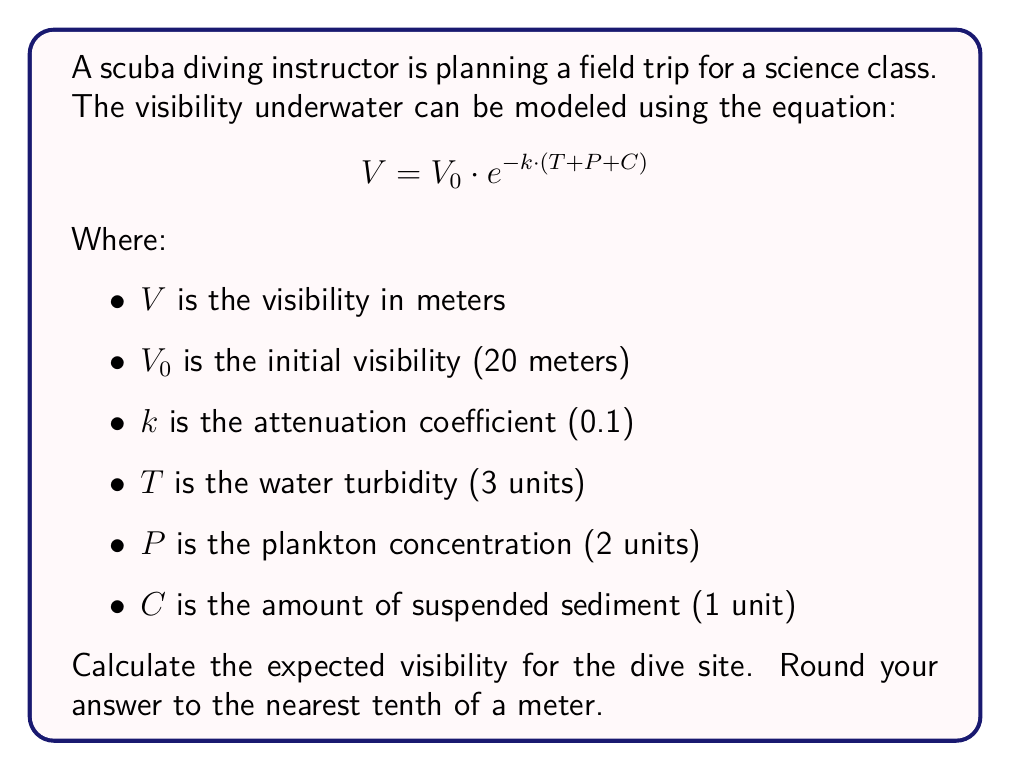Give your solution to this math problem. To solve this problem, we'll follow these steps:

1) We're given the equation: $V = V_0 \cdot e^{-k \cdot (T + P + C)}$

2) We know the following values:
   $V_0 = 20$ meters
   $k = 0.1$
   $T = 3$ units
   $P = 2$ units
   $C = 1$ unit

3) Let's start by calculating the sum of $T + P + C$:
   $T + P + C = 3 + 2 + 1 = 6$

4) Now we can substitute all known values into the equation:
   $V = 20 \cdot e^{-0.1 \cdot 6}$

5) Simplify the exponent:
   $V = 20 \cdot e^{-0.6}$

6) Calculate $e^{-0.6}$ (you can use a calculator for this):
   $e^{-0.6} \approx 0.5488$

7) Multiply:
   $V = 20 \cdot 0.5488 = 10.976$ meters

8) Rounding to the nearest tenth:
   $V \approx 11.0$ meters

Therefore, the expected visibility for the dive site is approximately 11.0 meters.
Answer: 11.0 meters 